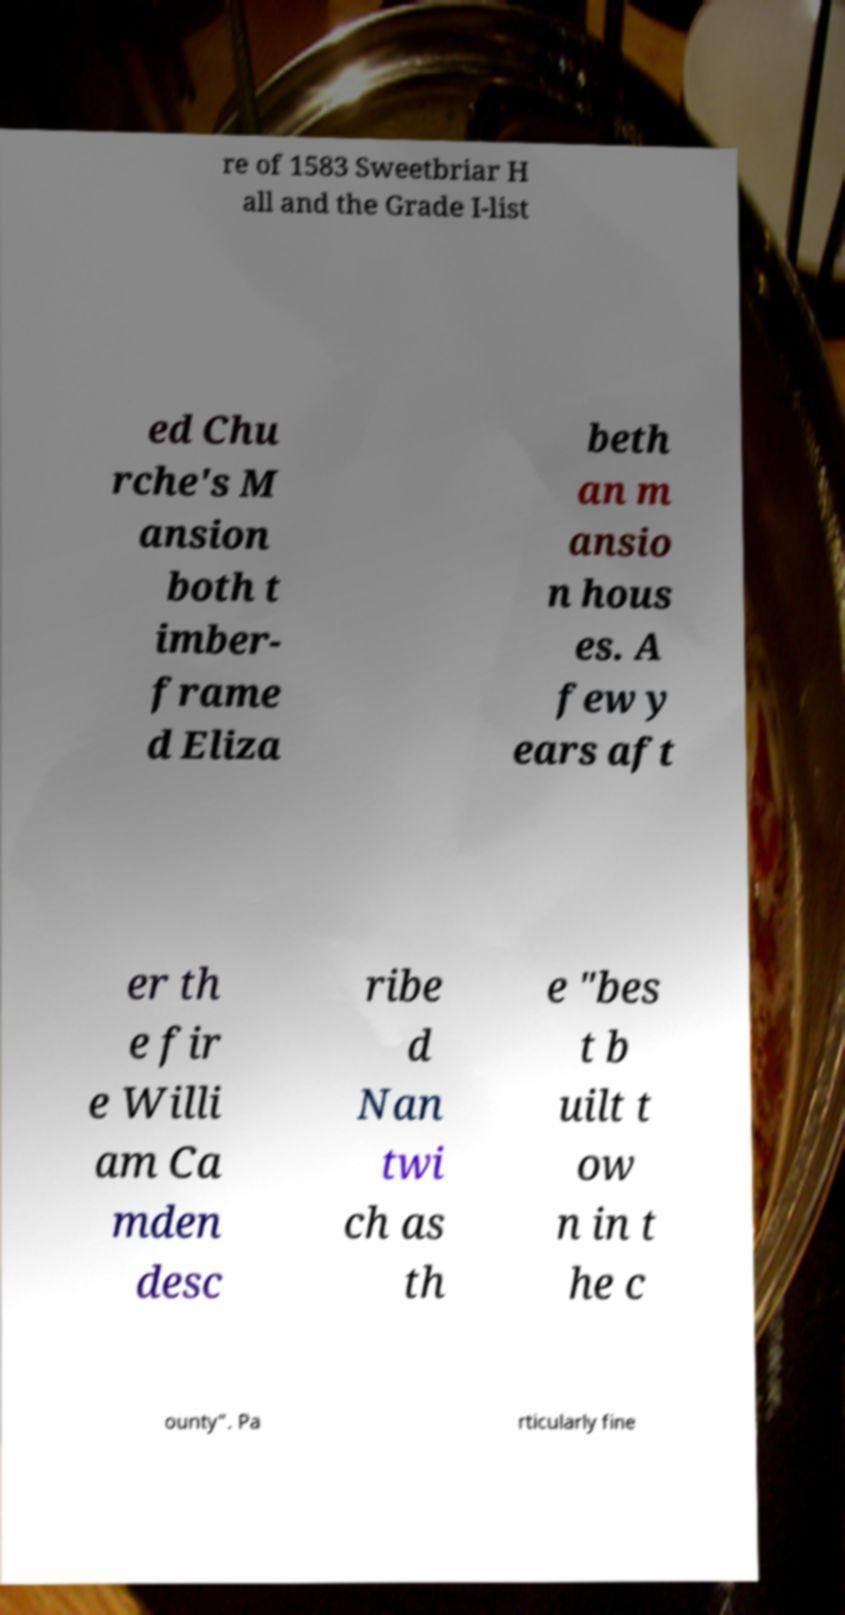Please read and relay the text visible in this image. What does it say? re of 1583 Sweetbriar H all and the Grade I-list ed Chu rche's M ansion both t imber- frame d Eliza beth an m ansio n hous es. A few y ears aft er th e fir e Willi am Ca mden desc ribe d Nan twi ch as th e "bes t b uilt t ow n in t he c ounty". Pa rticularly fine 